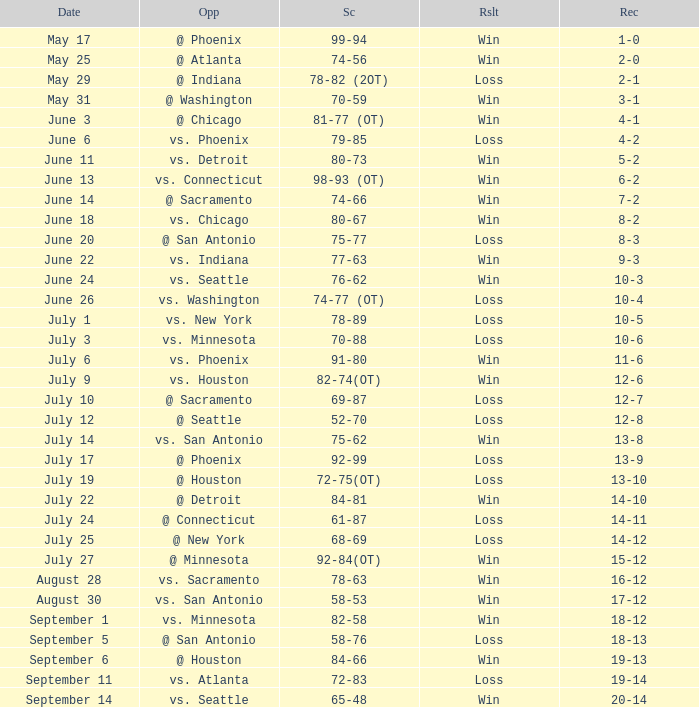What is the Record of the game on September 6? 19-13. 